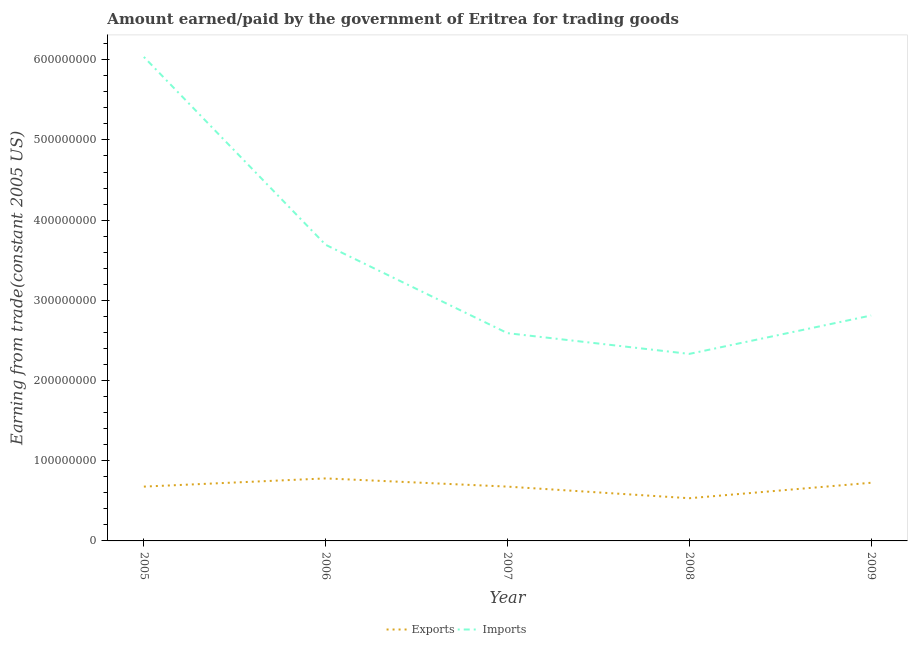Is the number of lines equal to the number of legend labels?
Offer a terse response. Yes. What is the amount earned from exports in 2008?
Your answer should be very brief. 5.32e+07. Across all years, what is the maximum amount paid for imports?
Make the answer very short. 6.03e+08. Across all years, what is the minimum amount paid for imports?
Keep it short and to the point. 2.33e+08. In which year was the amount paid for imports minimum?
Keep it short and to the point. 2008. What is the total amount earned from exports in the graph?
Your answer should be compact. 3.39e+08. What is the difference between the amount paid for imports in 2005 and that in 2006?
Keep it short and to the point. 2.34e+08. What is the difference between the amount earned from exports in 2007 and the amount paid for imports in 2005?
Make the answer very short. -5.36e+08. What is the average amount earned from exports per year?
Offer a terse response. 6.78e+07. In the year 2006, what is the difference between the amount paid for imports and amount earned from exports?
Make the answer very short. 2.91e+08. What is the ratio of the amount paid for imports in 2006 to that in 2007?
Keep it short and to the point. 1.43. Is the amount paid for imports in 2007 less than that in 2008?
Offer a very short reply. No. Is the difference between the amount paid for imports in 2006 and 2009 greater than the difference between the amount earned from exports in 2006 and 2009?
Offer a terse response. Yes. What is the difference between the highest and the second highest amount paid for imports?
Give a very brief answer. 2.34e+08. What is the difference between the highest and the lowest amount paid for imports?
Ensure brevity in your answer.  3.70e+08. In how many years, is the amount earned from exports greater than the average amount earned from exports taken over all years?
Your answer should be compact. 2. Is the sum of the amount earned from exports in 2007 and 2008 greater than the maximum amount paid for imports across all years?
Your answer should be very brief. No. Does the amount paid for imports monotonically increase over the years?
Keep it short and to the point. No. Is the amount earned from exports strictly greater than the amount paid for imports over the years?
Your response must be concise. No. Is the amount paid for imports strictly less than the amount earned from exports over the years?
Provide a short and direct response. No. How many lines are there?
Make the answer very short. 2. How many years are there in the graph?
Provide a short and direct response. 5. What is the title of the graph?
Offer a very short reply. Amount earned/paid by the government of Eritrea for trading goods. Does "Under-5(male)" appear as one of the legend labels in the graph?
Offer a very short reply. No. What is the label or title of the X-axis?
Give a very brief answer. Year. What is the label or title of the Y-axis?
Your response must be concise. Earning from trade(constant 2005 US). What is the Earning from trade(constant 2005 US) of Exports in 2005?
Provide a succinct answer. 6.77e+07. What is the Earning from trade(constant 2005 US) of Imports in 2005?
Your answer should be very brief. 6.03e+08. What is the Earning from trade(constant 2005 US) of Exports in 2006?
Your response must be concise. 7.80e+07. What is the Earning from trade(constant 2005 US) in Imports in 2006?
Ensure brevity in your answer.  3.69e+08. What is the Earning from trade(constant 2005 US) in Exports in 2007?
Ensure brevity in your answer.  6.77e+07. What is the Earning from trade(constant 2005 US) of Imports in 2007?
Ensure brevity in your answer.  2.59e+08. What is the Earning from trade(constant 2005 US) in Exports in 2008?
Your answer should be compact. 5.32e+07. What is the Earning from trade(constant 2005 US) of Imports in 2008?
Ensure brevity in your answer.  2.33e+08. What is the Earning from trade(constant 2005 US) of Exports in 2009?
Give a very brief answer. 7.25e+07. What is the Earning from trade(constant 2005 US) in Imports in 2009?
Offer a very short reply. 2.81e+08. Across all years, what is the maximum Earning from trade(constant 2005 US) in Exports?
Make the answer very short. 7.80e+07. Across all years, what is the maximum Earning from trade(constant 2005 US) in Imports?
Provide a succinct answer. 6.03e+08. Across all years, what is the minimum Earning from trade(constant 2005 US) of Exports?
Offer a terse response. 5.32e+07. Across all years, what is the minimum Earning from trade(constant 2005 US) of Imports?
Your answer should be very brief. 2.33e+08. What is the total Earning from trade(constant 2005 US) of Exports in the graph?
Your answer should be compact. 3.39e+08. What is the total Earning from trade(constant 2005 US) in Imports in the graph?
Offer a very short reply. 1.75e+09. What is the difference between the Earning from trade(constant 2005 US) in Exports in 2005 and that in 2006?
Make the answer very short. -1.02e+07. What is the difference between the Earning from trade(constant 2005 US) in Imports in 2005 and that in 2006?
Provide a succinct answer. 2.34e+08. What is the difference between the Earning from trade(constant 2005 US) in Exports in 2005 and that in 2007?
Your answer should be compact. 9360.53. What is the difference between the Earning from trade(constant 2005 US) of Imports in 2005 and that in 2007?
Provide a succinct answer. 3.44e+08. What is the difference between the Earning from trade(constant 2005 US) in Exports in 2005 and that in 2008?
Your response must be concise. 1.45e+07. What is the difference between the Earning from trade(constant 2005 US) of Imports in 2005 and that in 2008?
Your answer should be very brief. 3.70e+08. What is the difference between the Earning from trade(constant 2005 US) in Exports in 2005 and that in 2009?
Offer a very short reply. -4.80e+06. What is the difference between the Earning from trade(constant 2005 US) of Imports in 2005 and that in 2009?
Make the answer very short. 3.22e+08. What is the difference between the Earning from trade(constant 2005 US) in Exports in 2006 and that in 2007?
Give a very brief answer. 1.02e+07. What is the difference between the Earning from trade(constant 2005 US) of Imports in 2006 and that in 2007?
Offer a very short reply. 1.10e+08. What is the difference between the Earning from trade(constant 2005 US) of Exports in 2006 and that in 2008?
Give a very brief answer. 2.47e+07. What is the difference between the Earning from trade(constant 2005 US) of Imports in 2006 and that in 2008?
Provide a succinct answer. 1.36e+08. What is the difference between the Earning from trade(constant 2005 US) of Exports in 2006 and that in 2009?
Give a very brief answer. 5.43e+06. What is the difference between the Earning from trade(constant 2005 US) of Imports in 2006 and that in 2009?
Offer a very short reply. 8.81e+07. What is the difference between the Earning from trade(constant 2005 US) of Exports in 2007 and that in 2008?
Your answer should be very brief. 1.45e+07. What is the difference between the Earning from trade(constant 2005 US) in Imports in 2007 and that in 2008?
Offer a very short reply. 2.59e+07. What is the difference between the Earning from trade(constant 2005 US) of Exports in 2007 and that in 2009?
Your answer should be compact. -4.81e+06. What is the difference between the Earning from trade(constant 2005 US) of Imports in 2007 and that in 2009?
Provide a succinct answer. -2.20e+07. What is the difference between the Earning from trade(constant 2005 US) in Exports in 2008 and that in 2009?
Keep it short and to the point. -1.93e+07. What is the difference between the Earning from trade(constant 2005 US) in Imports in 2008 and that in 2009?
Your answer should be compact. -4.79e+07. What is the difference between the Earning from trade(constant 2005 US) of Exports in 2005 and the Earning from trade(constant 2005 US) of Imports in 2006?
Offer a very short reply. -3.01e+08. What is the difference between the Earning from trade(constant 2005 US) of Exports in 2005 and the Earning from trade(constant 2005 US) of Imports in 2007?
Your answer should be compact. -1.91e+08. What is the difference between the Earning from trade(constant 2005 US) in Exports in 2005 and the Earning from trade(constant 2005 US) in Imports in 2008?
Offer a terse response. -1.65e+08. What is the difference between the Earning from trade(constant 2005 US) of Exports in 2005 and the Earning from trade(constant 2005 US) of Imports in 2009?
Make the answer very short. -2.13e+08. What is the difference between the Earning from trade(constant 2005 US) of Exports in 2006 and the Earning from trade(constant 2005 US) of Imports in 2007?
Provide a short and direct response. -1.81e+08. What is the difference between the Earning from trade(constant 2005 US) of Exports in 2006 and the Earning from trade(constant 2005 US) of Imports in 2008?
Provide a short and direct response. -1.55e+08. What is the difference between the Earning from trade(constant 2005 US) of Exports in 2006 and the Earning from trade(constant 2005 US) of Imports in 2009?
Offer a very short reply. -2.03e+08. What is the difference between the Earning from trade(constant 2005 US) in Exports in 2007 and the Earning from trade(constant 2005 US) in Imports in 2008?
Offer a terse response. -1.65e+08. What is the difference between the Earning from trade(constant 2005 US) of Exports in 2007 and the Earning from trade(constant 2005 US) of Imports in 2009?
Make the answer very short. -2.13e+08. What is the difference between the Earning from trade(constant 2005 US) in Exports in 2008 and the Earning from trade(constant 2005 US) in Imports in 2009?
Give a very brief answer. -2.28e+08. What is the average Earning from trade(constant 2005 US) of Exports per year?
Ensure brevity in your answer.  6.78e+07. What is the average Earning from trade(constant 2005 US) of Imports per year?
Provide a succinct answer. 3.49e+08. In the year 2005, what is the difference between the Earning from trade(constant 2005 US) in Exports and Earning from trade(constant 2005 US) in Imports?
Provide a short and direct response. -5.36e+08. In the year 2006, what is the difference between the Earning from trade(constant 2005 US) of Exports and Earning from trade(constant 2005 US) of Imports?
Your answer should be compact. -2.91e+08. In the year 2007, what is the difference between the Earning from trade(constant 2005 US) in Exports and Earning from trade(constant 2005 US) in Imports?
Your response must be concise. -1.91e+08. In the year 2008, what is the difference between the Earning from trade(constant 2005 US) of Exports and Earning from trade(constant 2005 US) of Imports?
Ensure brevity in your answer.  -1.80e+08. In the year 2009, what is the difference between the Earning from trade(constant 2005 US) in Exports and Earning from trade(constant 2005 US) in Imports?
Offer a very short reply. -2.09e+08. What is the ratio of the Earning from trade(constant 2005 US) in Exports in 2005 to that in 2006?
Keep it short and to the point. 0.87. What is the ratio of the Earning from trade(constant 2005 US) of Imports in 2005 to that in 2006?
Provide a succinct answer. 1.63. What is the ratio of the Earning from trade(constant 2005 US) of Imports in 2005 to that in 2007?
Keep it short and to the point. 2.33. What is the ratio of the Earning from trade(constant 2005 US) in Exports in 2005 to that in 2008?
Offer a very short reply. 1.27. What is the ratio of the Earning from trade(constant 2005 US) of Imports in 2005 to that in 2008?
Give a very brief answer. 2.59. What is the ratio of the Earning from trade(constant 2005 US) of Exports in 2005 to that in 2009?
Your answer should be very brief. 0.93. What is the ratio of the Earning from trade(constant 2005 US) in Imports in 2005 to that in 2009?
Offer a terse response. 2.15. What is the ratio of the Earning from trade(constant 2005 US) in Exports in 2006 to that in 2007?
Provide a short and direct response. 1.15. What is the ratio of the Earning from trade(constant 2005 US) in Imports in 2006 to that in 2007?
Ensure brevity in your answer.  1.43. What is the ratio of the Earning from trade(constant 2005 US) of Exports in 2006 to that in 2008?
Give a very brief answer. 1.46. What is the ratio of the Earning from trade(constant 2005 US) in Imports in 2006 to that in 2008?
Offer a very short reply. 1.58. What is the ratio of the Earning from trade(constant 2005 US) of Exports in 2006 to that in 2009?
Your response must be concise. 1.07. What is the ratio of the Earning from trade(constant 2005 US) of Imports in 2006 to that in 2009?
Offer a very short reply. 1.31. What is the ratio of the Earning from trade(constant 2005 US) of Exports in 2007 to that in 2008?
Make the answer very short. 1.27. What is the ratio of the Earning from trade(constant 2005 US) of Imports in 2007 to that in 2008?
Provide a short and direct response. 1.11. What is the ratio of the Earning from trade(constant 2005 US) of Exports in 2007 to that in 2009?
Offer a very short reply. 0.93. What is the ratio of the Earning from trade(constant 2005 US) in Imports in 2007 to that in 2009?
Offer a very short reply. 0.92. What is the ratio of the Earning from trade(constant 2005 US) in Exports in 2008 to that in 2009?
Provide a succinct answer. 0.73. What is the ratio of the Earning from trade(constant 2005 US) in Imports in 2008 to that in 2009?
Give a very brief answer. 0.83. What is the difference between the highest and the second highest Earning from trade(constant 2005 US) in Exports?
Offer a very short reply. 5.43e+06. What is the difference between the highest and the second highest Earning from trade(constant 2005 US) in Imports?
Keep it short and to the point. 2.34e+08. What is the difference between the highest and the lowest Earning from trade(constant 2005 US) in Exports?
Ensure brevity in your answer.  2.47e+07. What is the difference between the highest and the lowest Earning from trade(constant 2005 US) in Imports?
Your answer should be compact. 3.70e+08. 